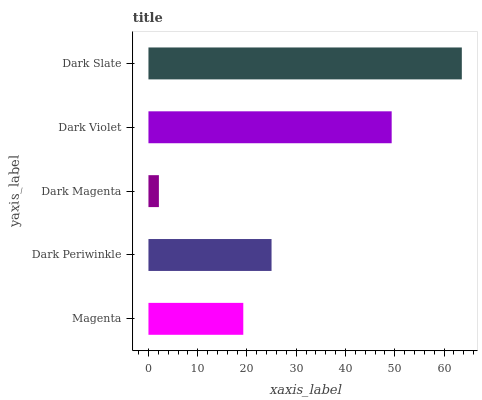Is Dark Magenta the minimum?
Answer yes or no. Yes. Is Dark Slate the maximum?
Answer yes or no. Yes. Is Dark Periwinkle the minimum?
Answer yes or no. No. Is Dark Periwinkle the maximum?
Answer yes or no. No. Is Dark Periwinkle greater than Magenta?
Answer yes or no. Yes. Is Magenta less than Dark Periwinkle?
Answer yes or no. Yes. Is Magenta greater than Dark Periwinkle?
Answer yes or no. No. Is Dark Periwinkle less than Magenta?
Answer yes or no. No. Is Dark Periwinkle the high median?
Answer yes or no. Yes. Is Dark Periwinkle the low median?
Answer yes or no. Yes. Is Dark Violet the high median?
Answer yes or no. No. Is Dark Slate the low median?
Answer yes or no. No. 